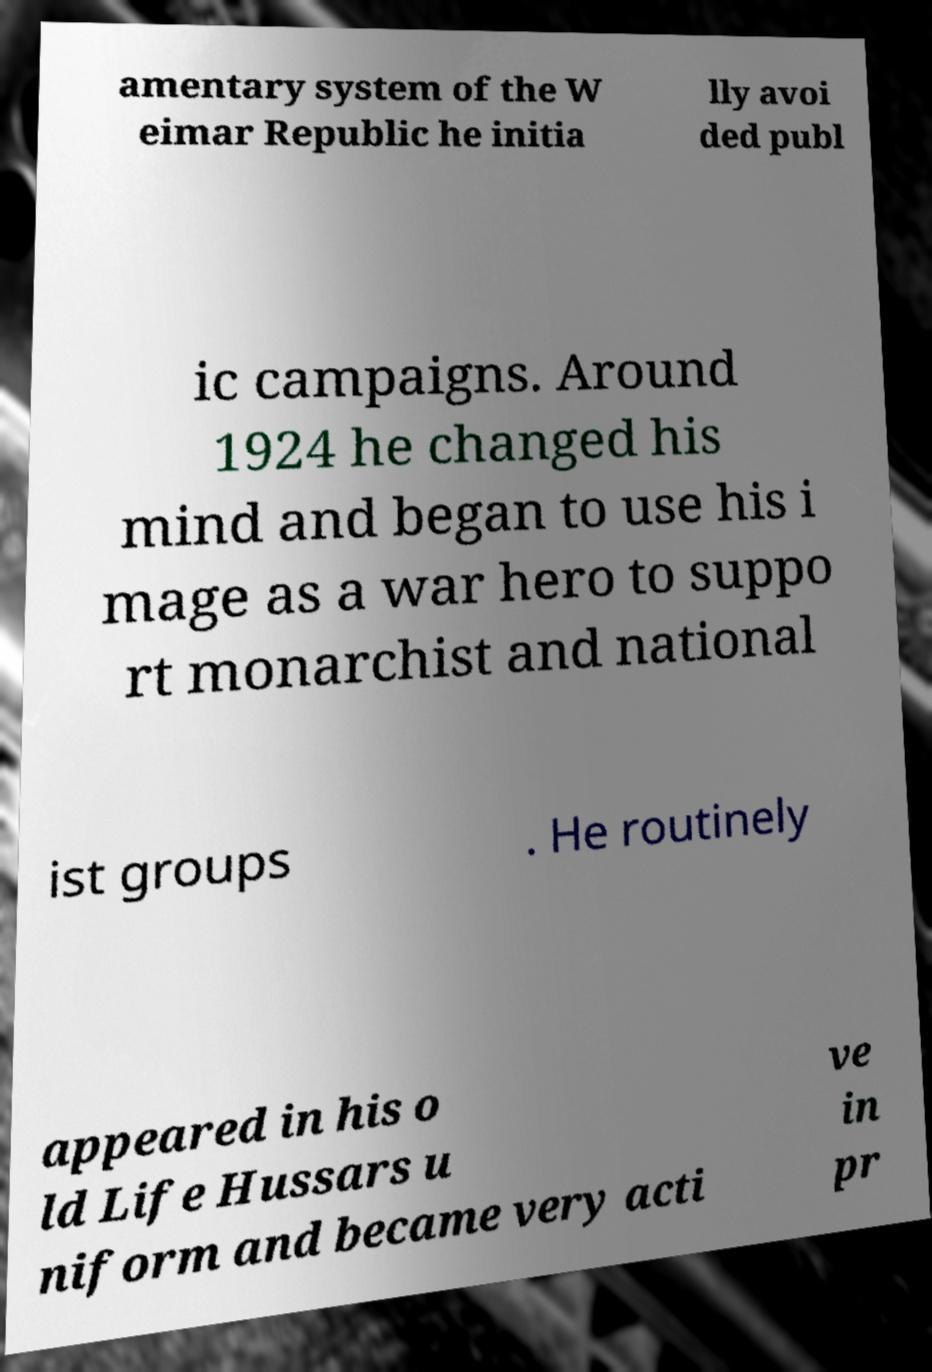Can you accurately transcribe the text from the provided image for me? amentary system of the W eimar Republic he initia lly avoi ded publ ic campaigns. Around 1924 he changed his mind and began to use his i mage as a war hero to suppo rt monarchist and national ist groups . He routinely appeared in his o ld Life Hussars u niform and became very acti ve in pr 